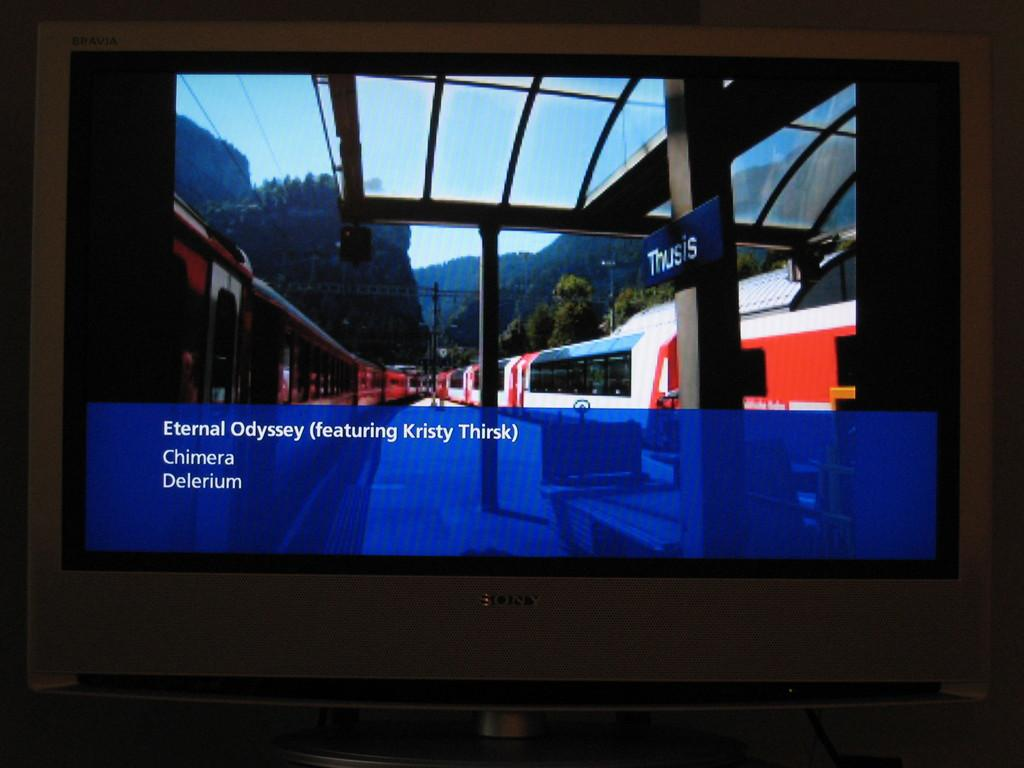<image>
Give a short and clear explanation of the subsequent image. A picture of a train with the words Eternal Odyssey under it. 